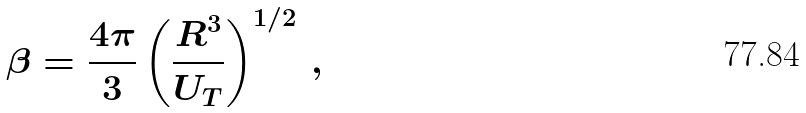Convert formula to latex. <formula><loc_0><loc_0><loc_500><loc_500>\beta = \frac { 4 \pi } { 3 } \left ( \frac { R ^ { 3 } } { U _ { T } } \right ) ^ { 1 / 2 } \, ,</formula> 